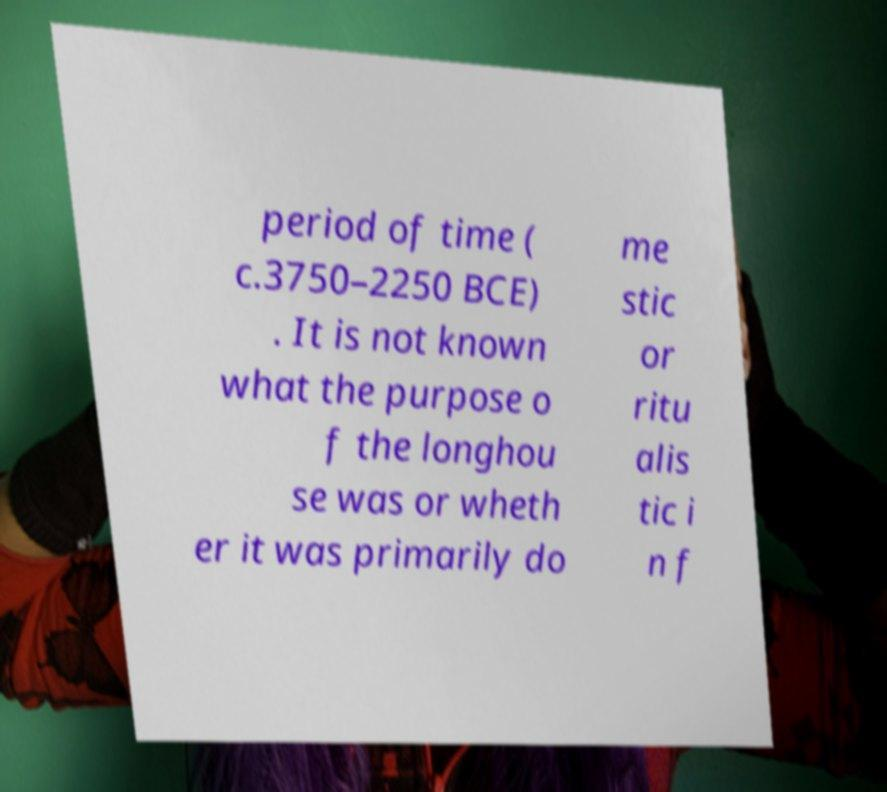Can you read and provide the text displayed in the image?This photo seems to have some interesting text. Can you extract and type it out for me? period of time ( c.3750–2250 BCE) . It is not known what the purpose o f the longhou se was or wheth er it was primarily do me stic or ritu alis tic i n f 